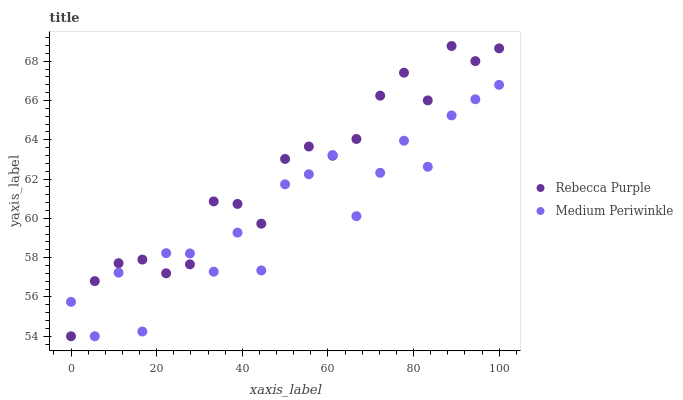Does Medium Periwinkle have the minimum area under the curve?
Answer yes or no. Yes. Does Rebecca Purple have the maximum area under the curve?
Answer yes or no. Yes. Does Rebecca Purple have the minimum area under the curve?
Answer yes or no. No. Is Rebecca Purple the smoothest?
Answer yes or no. Yes. Is Medium Periwinkle the roughest?
Answer yes or no. Yes. Is Rebecca Purple the roughest?
Answer yes or no. No. Does Medium Periwinkle have the lowest value?
Answer yes or no. Yes. Does Rebecca Purple have the highest value?
Answer yes or no. Yes. Does Medium Periwinkle intersect Rebecca Purple?
Answer yes or no. Yes. Is Medium Periwinkle less than Rebecca Purple?
Answer yes or no. No. Is Medium Periwinkle greater than Rebecca Purple?
Answer yes or no. No. 